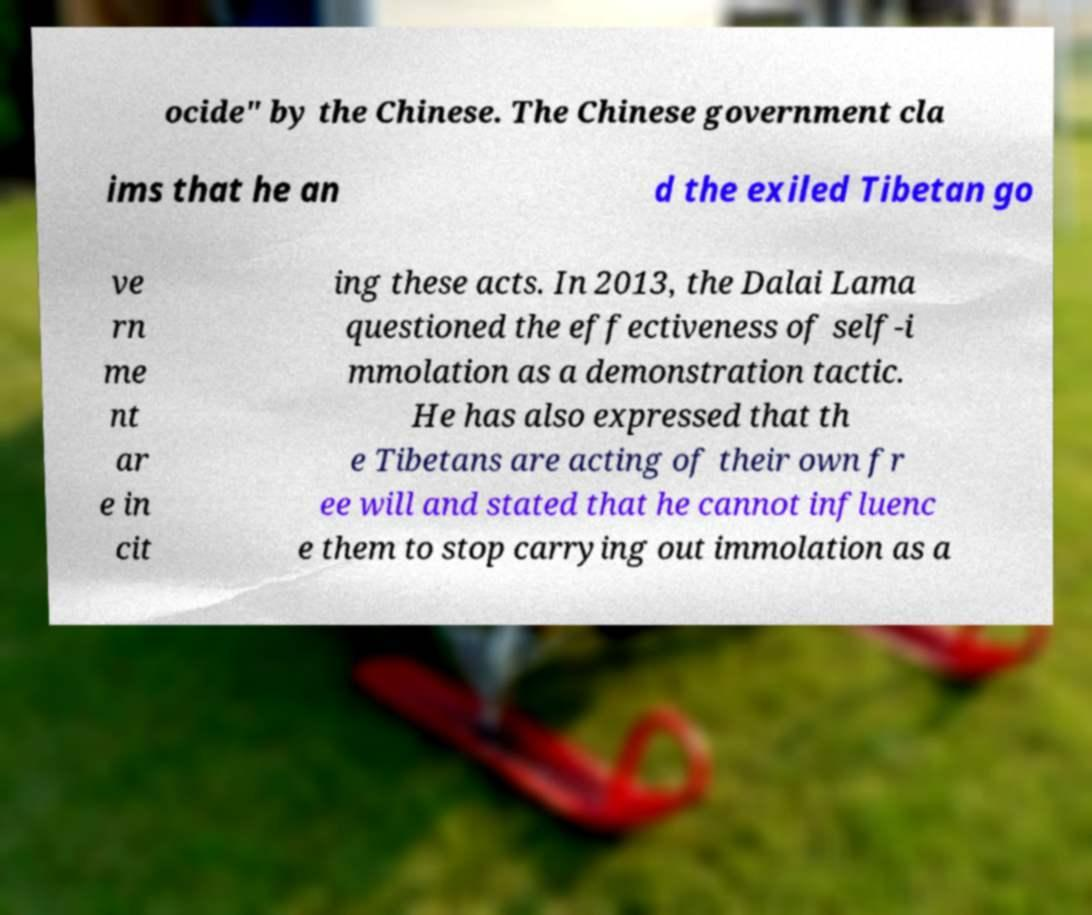Please identify and transcribe the text found in this image. ocide" by the Chinese. The Chinese government cla ims that he an d the exiled Tibetan go ve rn me nt ar e in cit ing these acts. In 2013, the Dalai Lama questioned the effectiveness of self-i mmolation as a demonstration tactic. He has also expressed that th e Tibetans are acting of their own fr ee will and stated that he cannot influenc e them to stop carrying out immolation as a 